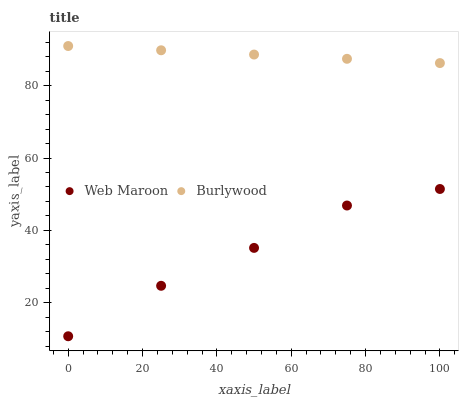Does Web Maroon have the minimum area under the curve?
Answer yes or no. Yes. Does Burlywood have the maximum area under the curve?
Answer yes or no. Yes. Does Web Maroon have the maximum area under the curve?
Answer yes or no. No. Is Burlywood the smoothest?
Answer yes or no. Yes. Is Web Maroon the roughest?
Answer yes or no. Yes. Is Web Maroon the smoothest?
Answer yes or no. No. Does Web Maroon have the lowest value?
Answer yes or no. Yes. Does Burlywood have the highest value?
Answer yes or no. Yes. Does Web Maroon have the highest value?
Answer yes or no. No. Is Web Maroon less than Burlywood?
Answer yes or no. Yes. Is Burlywood greater than Web Maroon?
Answer yes or no. Yes. Does Web Maroon intersect Burlywood?
Answer yes or no. No. 